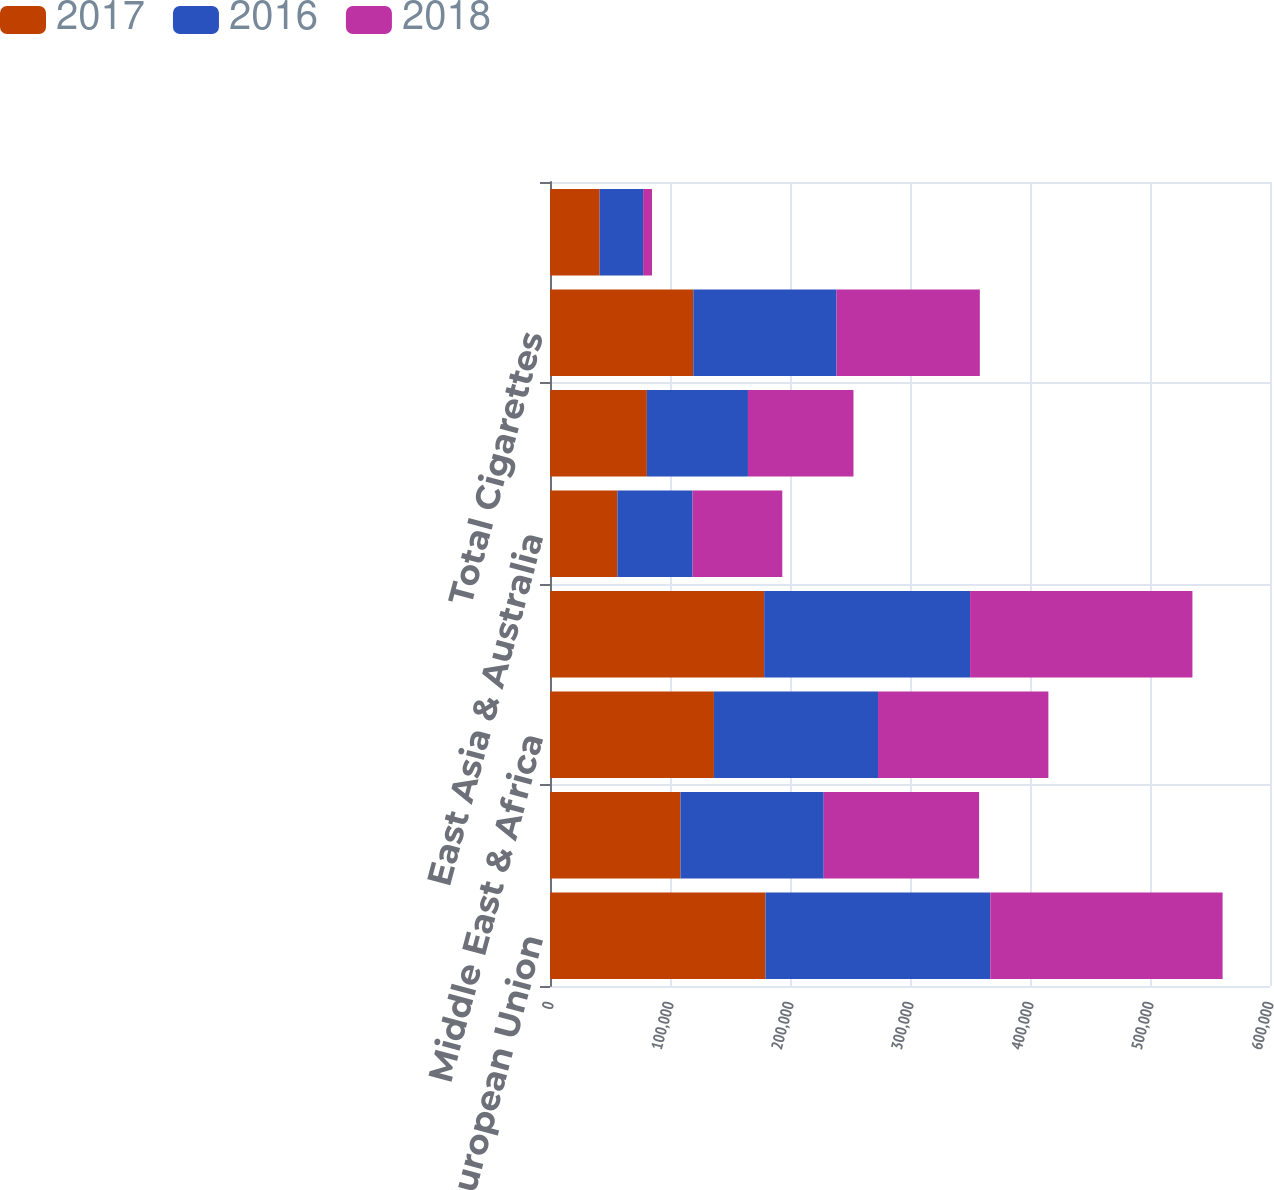<chart> <loc_0><loc_0><loc_500><loc_500><stacked_bar_chart><ecel><fcel>European Union<fcel>Eastern Europe<fcel>Middle East & Africa<fcel>South & Southeast Asia<fcel>East Asia & Australia<fcel>Latin America & Canada<fcel>Total Cigarettes<fcel>Total Heated Tobacco Units<nl><fcel>2017<fcel>179622<fcel>108718<fcel>136605<fcel>178469<fcel>56163<fcel>80738<fcel>119398<fcel>41372<nl><fcel>2016<fcel>187293<fcel>119398<fcel>136759<fcel>171600<fcel>62653<fcel>84223<fcel>119398<fcel>36226<nl><fcel>2018<fcel>193586<fcel>129456<fcel>141937<fcel>185279<fcel>74750<fcel>87938<fcel>119398<fcel>7394<nl></chart> 